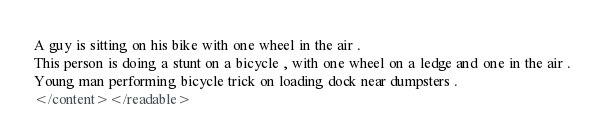<code> <loc_0><loc_0><loc_500><loc_500><_XML_>A guy is sitting on his bike with one wheel in the air .
This person is doing a stunt on a bicycle , with one wheel on a ledge and one in the air .
Young man performing bicycle trick on loading dock near dumpsters .
</content></readable></code> 